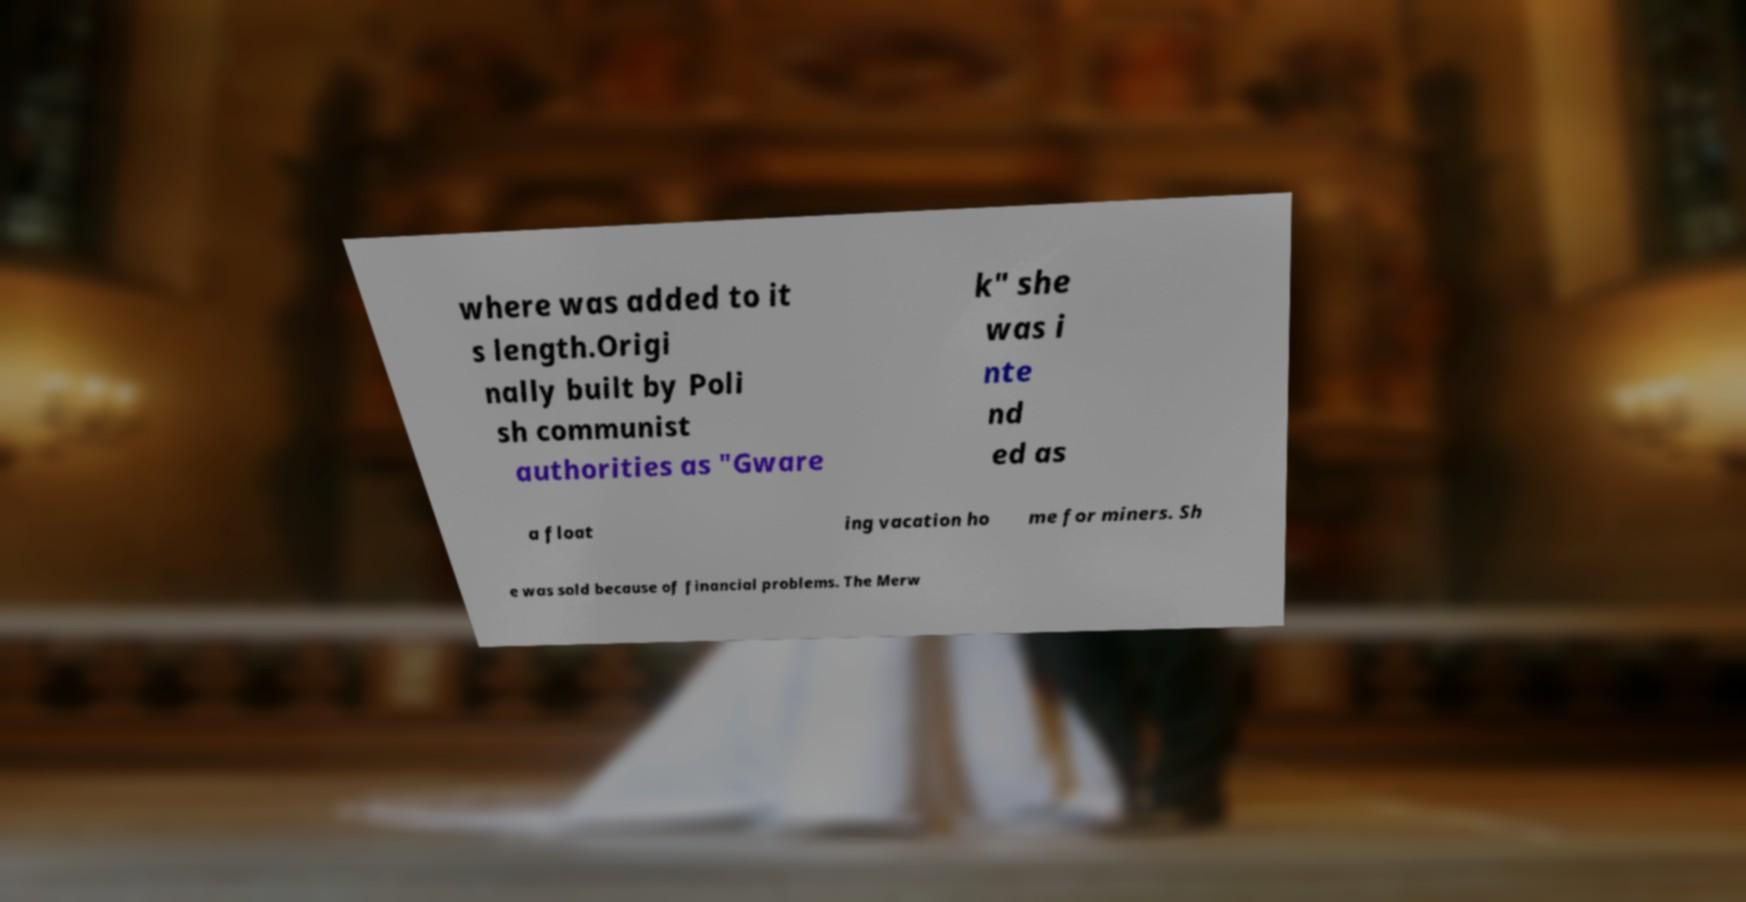There's text embedded in this image that I need extracted. Can you transcribe it verbatim? where was added to it s length.Origi nally built by Poli sh communist authorities as "Gware k" she was i nte nd ed as a float ing vacation ho me for miners. Sh e was sold because of financial problems. The Merw 